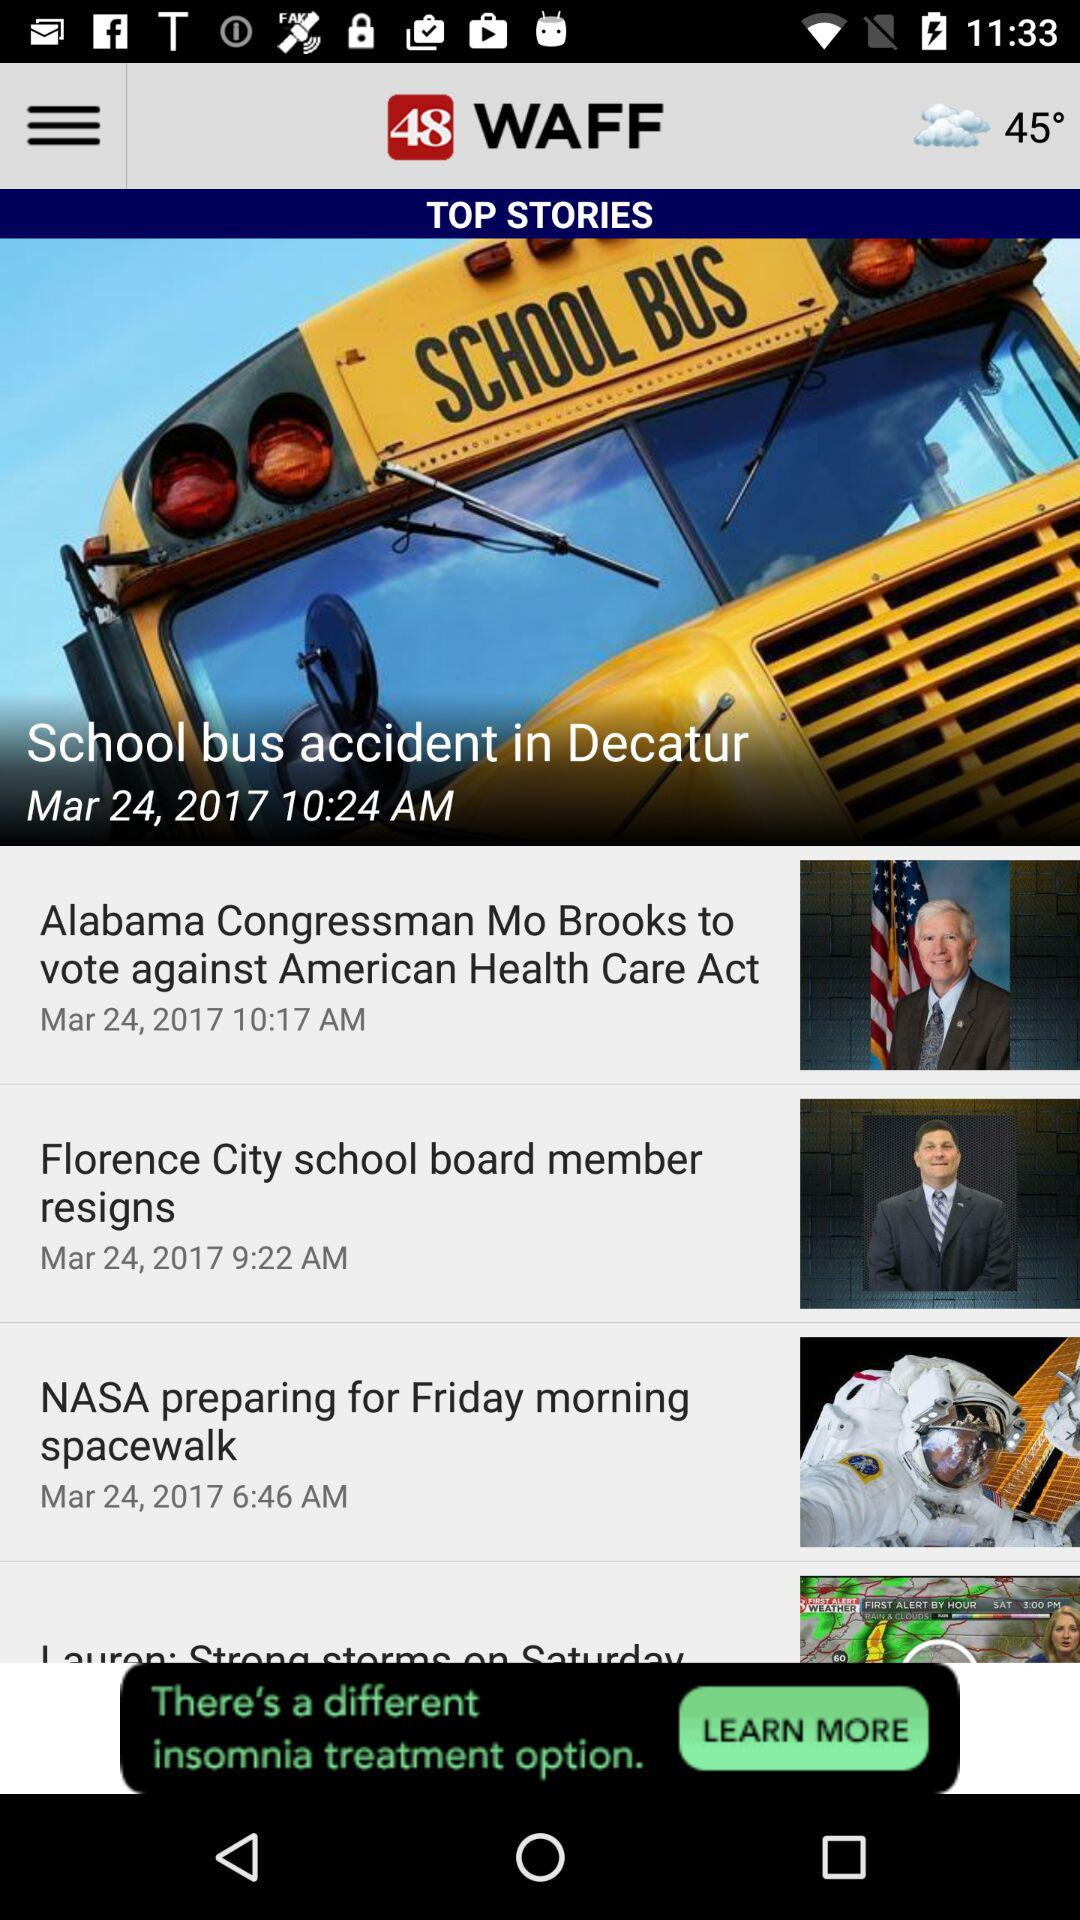On which date was "NASA preparing for Friday morning spacewalk" posted? It was posted on March 24, 2017. 